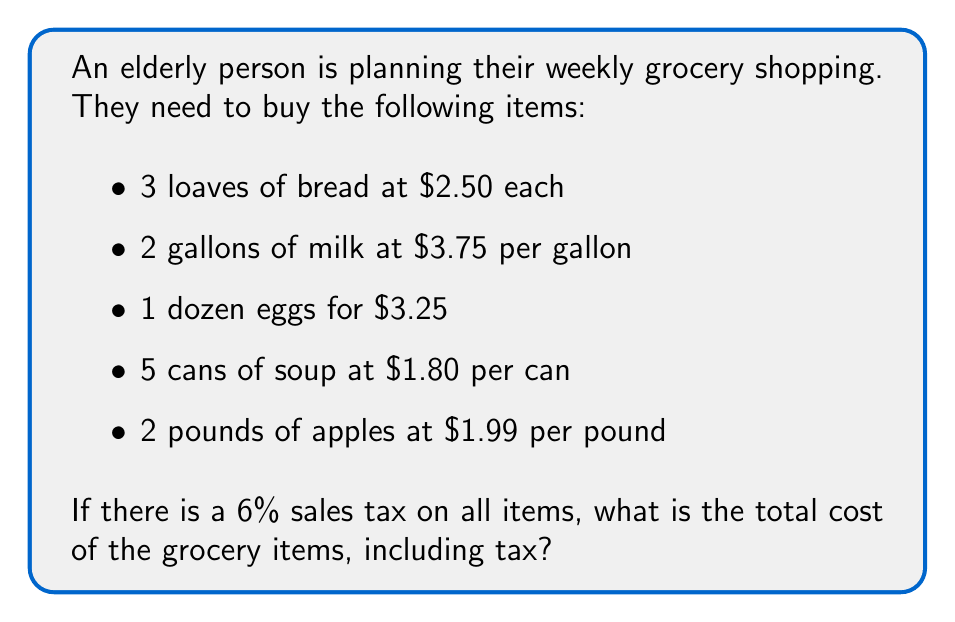Provide a solution to this math problem. Let's break this down step-by-step:

1. Calculate the cost of bread:
   $3 \times $2.50 = $7.50$

2. Calculate the cost of milk:
   $2 \times $3.75 = $7.50$

3. Cost of eggs is already given:
   $3.25$

4. Calculate the cost of soup:
   $5 \times $1.80 = $9.00$

5. Calculate the cost of apples:
   $2 \times $1.99 = $3.98$

6. Sum up the subtotal:
   $$7.50 + 7.50 + 3.25 + 9.00 + 3.98 = $31.23$$

7. Calculate the 6% sales tax:
   $$31.23 \times 0.06 = $1.8738$$

8. Add the tax to the subtotal:
   $$31.23 + 1.8738 = $33.1038$$

9. Round to the nearest cent:
   $33.10$
Answer: $33.10 